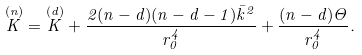<formula> <loc_0><loc_0><loc_500><loc_500>\overset { ( n ) } { K } = \overset { ( d ) } { K } + \frac { 2 ( n - d ) ( n - d - 1 ) { \bar { k } } ^ { 2 } } { r _ { 0 } ^ { 4 } } + \frac { ( n - d ) \Theta } { r _ { 0 } ^ { 4 } } .</formula> 